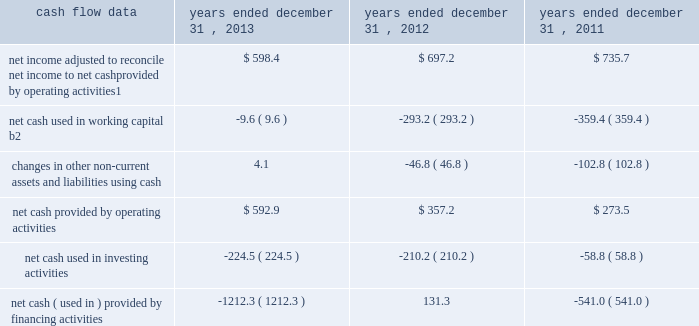Management 2019s discussion and analysis of financial condition and results of operations 2013 ( continued ) ( amounts in millions , except per share amounts ) corporate and other expenses decreased slightly during 2012 by $ 4.7 to $ 137.3 compared to 2011 , primarily due to lower office and general expenses , partially offset by an increase in temporary help to support our information-technology system-upgrade initiatives .
Liquidity and capital resources cash flow overview the tables summarize key financial data relating to our liquidity , capital resources and uses of capital. .
1 reflects net income adjusted primarily for depreciation and amortization of fixed assets and intangible assets , amortization of restricted stock and other non-cash compensation , non-cash loss related to early extinguishment of debt , and deferred income taxes .
2 reflects changes in accounts receivable , expenditures billable to clients , other current assets , accounts payable and accrued liabilities .
Operating activities net cash provided by operating activities during 2013 was $ 592.9 , which was an increase of $ 235.7 as compared to 2012 , primarily as a result of an improvement in working capital usage of $ 283.6 , offset by a decrease in net income .
Due to the seasonality of our business , we typically generate cash from working capital in the second half of a year and use cash from working capital in the first half of a year , with the largest impacts in the first and fourth quarters .
The improvement in working capital in 2013 was impacted by our media businesses and an ongoing focus on working capital management at our agencies .
Net cash provided by operating activities during 2012 was $ 357.2 , which was an increase of $ 83.7 as compared to 2011 , primarily as a result of a decrease in working capital usage of $ 66.2 .
The net working capital usage in 2012 was primarily impacted by our media businesses .
The timing of media buying on behalf of our clients affects our working capital and operating cash flow .
In most of our businesses , our agencies enter into commitments to pay production and media costs on behalf of clients .
To the extent possible we pay production and media charges after we have received funds from our clients .
The amounts involved substantially exceed our revenues , and primarily affect the level of accounts receivable , expenditures billable to clients , accounts payable and accrued liabilities .
Our assets include both cash received and accounts receivable from clients for these pass-through arrangements , while our liabilities include amounts owed on behalf of clients to media and production suppliers .
Our accrued liabilities are also affected by the timing of certain other payments .
For example , while annual cash incentive awards are accrued throughout the year , they are generally paid during the first quarter of the subsequent year .
Investing activities net cash used in investing activities during 2013 primarily relates to payments for capital expenditures and acquisitions .
Capital expenditures of $ 173.0 relate primarily to computer hardware and software and leasehold improvements .
We made payments of $ 61.5 related to acquisitions completed during 2013. .
What portion of the change in net cash used for investing activities was used for capital expenditures in 2013? 
Computations: (173.0 / 224.5)
Answer: 0.7706. 